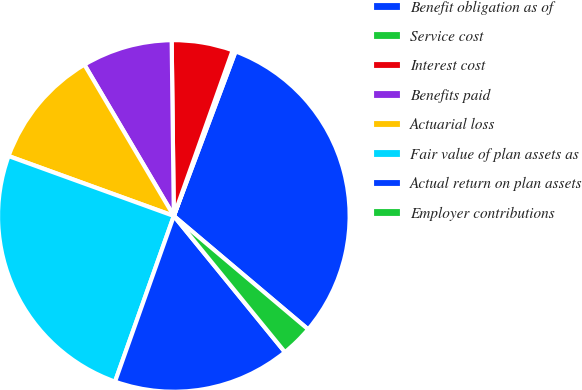Convert chart. <chart><loc_0><loc_0><loc_500><loc_500><pie_chart><fcel>Benefit obligation as of<fcel>Service cost<fcel>Interest cost<fcel>Benefits paid<fcel>Actuarial loss<fcel>Fair value of plan assets as<fcel>Actual return on plan assets<fcel>Employer contributions<nl><fcel>30.45%<fcel>0.28%<fcel>5.63%<fcel>8.3%<fcel>10.97%<fcel>25.11%<fcel>16.32%<fcel>2.95%<nl></chart> 